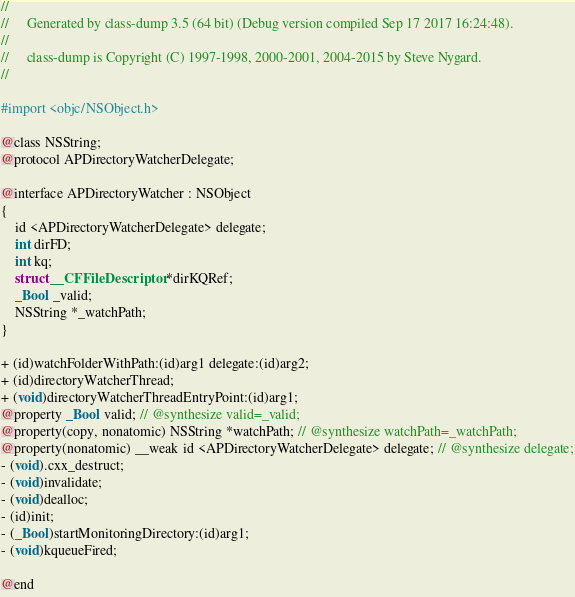Convert code to text. <code><loc_0><loc_0><loc_500><loc_500><_C_>//
//     Generated by class-dump 3.5 (64 bit) (Debug version compiled Sep 17 2017 16:24:48).
//
//     class-dump is Copyright (C) 1997-1998, 2000-2001, 2004-2015 by Steve Nygard.
//

#import <objc/NSObject.h>

@class NSString;
@protocol APDirectoryWatcherDelegate;

@interface APDirectoryWatcher : NSObject
{
    id <APDirectoryWatcherDelegate> delegate;
    int dirFD;
    int kq;
    struct __CFFileDescriptor *dirKQRef;
    _Bool _valid;
    NSString *_watchPath;
}

+ (id)watchFolderWithPath:(id)arg1 delegate:(id)arg2;
+ (id)directoryWatcherThread;
+ (void)directoryWatcherThreadEntryPoint:(id)arg1;
@property _Bool valid; // @synthesize valid=_valid;
@property(copy, nonatomic) NSString *watchPath; // @synthesize watchPath=_watchPath;
@property(nonatomic) __weak id <APDirectoryWatcherDelegate> delegate; // @synthesize delegate;
- (void).cxx_destruct;
- (void)invalidate;
- (void)dealloc;
- (id)init;
- (_Bool)startMonitoringDirectory:(id)arg1;
- (void)kqueueFired;

@end

</code> 